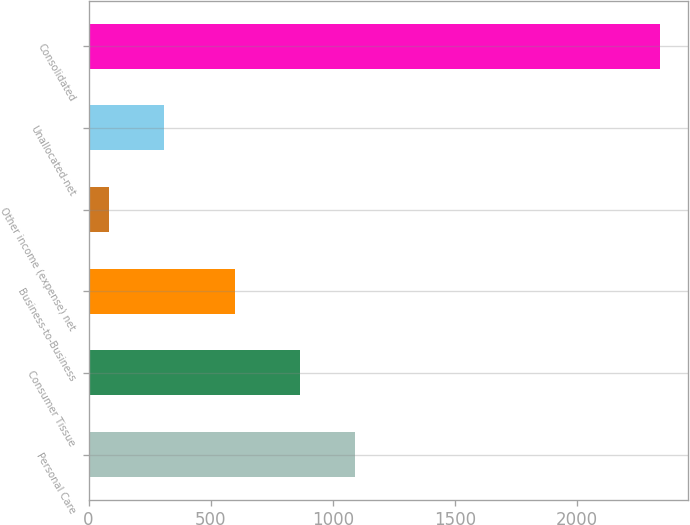<chart> <loc_0><loc_0><loc_500><loc_500><bar_chart><fcel>Personal Care<fcel>Consumer Tissue<fcel>Business-to-Business<fcel>Other income (expense) net<fcel>Unallocated-net<fcel>Consolidated<nl><fcel>1089.15<fcel>863.7<fcel>599.4<fcel>83.7<fcel>309.15<fcel>2338.2<nl></chart> 